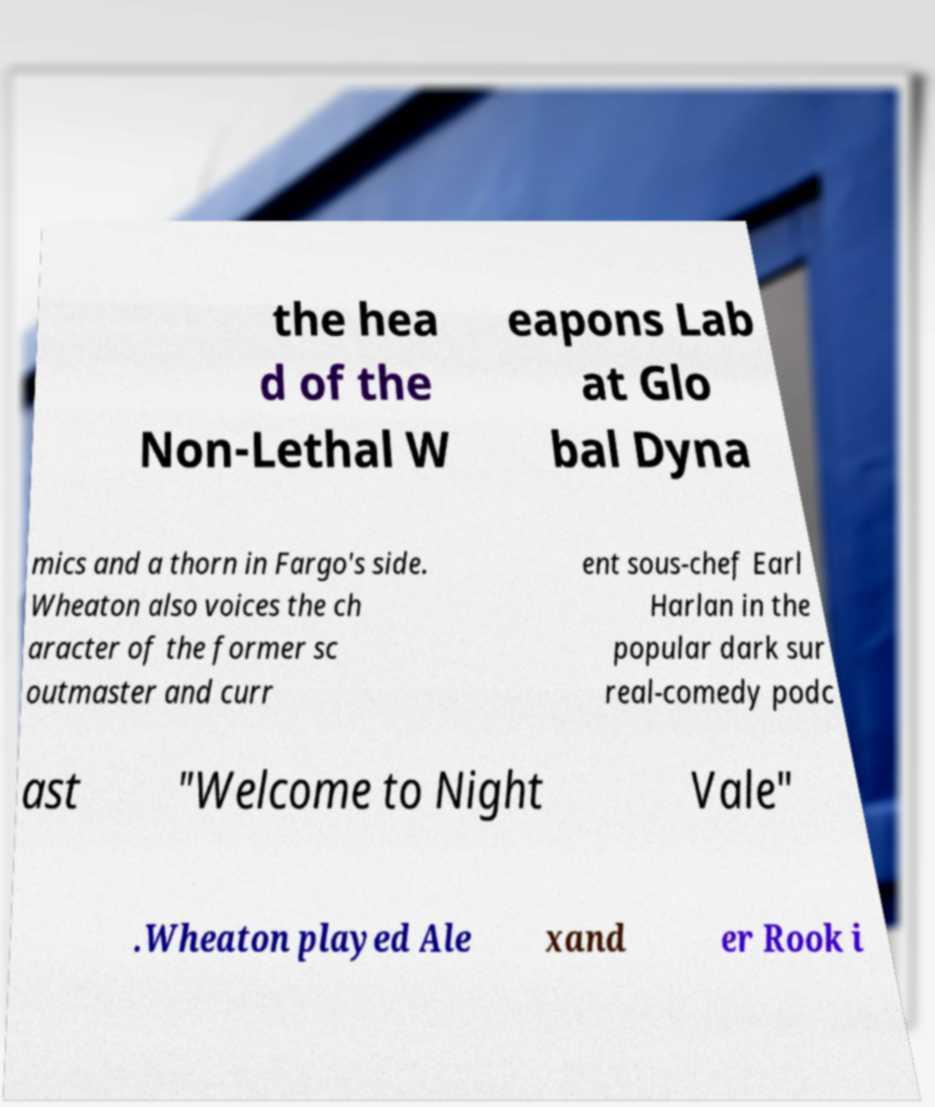For documentation purposes, I need the text within this image transcribed. Could you provide that? the hea d of the Non-Lethal W eapons Lab at Glo bal Dyna mics and a thorn in Fargo's side. Wheaton also voices the ch aracter of the former sc outmaster and curr ent sous-chef Earl Harlan in the popular dark sur real-comedy podc ast "Welcome to Night Vale" .Wheaton played Ale xand er Rook i 